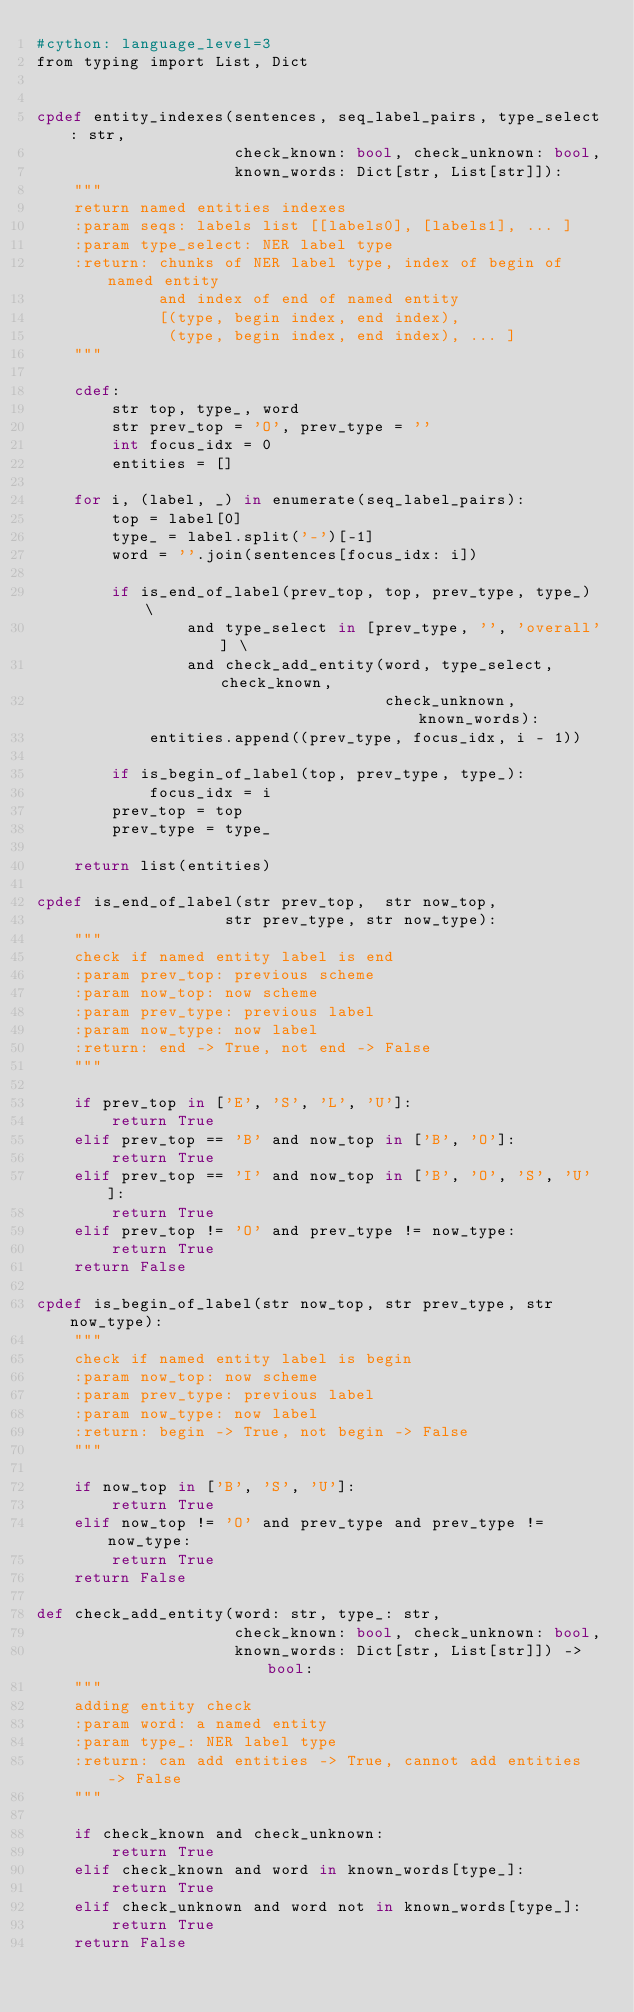Convert code to text. <code><loc_0><loc_0><loc_500><loc_500><_Cython_>#cython: language_level=3
from typing import List, Dict


cpdef entity_indexes(sentences, seq_label_pairs, type_select: str,
                     check_known: bool, check_unknown: bool,
                     known_words: Dict[str, List[str]]):
    """
    return named entities indexes
    :param seqs: labels list [[labels0], [labels1], ... ]
    :param type_select: NER label type
    :return: chunks of NER label type, index of begin of named entity
             and index of end of named entity
             [(type, begin index, end index),
              (type, begin index, end index), ... ]
    """

    cdef:
        str top, type_, word
        str prev_top = 'O', prev_type = ''
        int focus_idx = 0
        entities = []

    for i, (label, _) in enumerate(seq_label_pairs):
        top = label[0]
        type_ = label.split('-')[-1]
        word = ''.join(sentences[focus_idx: i])

        if is_end_of_label(prev_top, top, prev_type, type_) \
                and type_select in [prev_type, '', 'overall'] \
                and check_add_entity(word, type_select, check_known,
                                     check_unknown, known_words):
            entities.append((prev_type, focus_idx, i - 1))

        if is_begin_of_label(top, prev_type, type_):
            focus_idx = i
        prev_top = top
        prev_type = type_

    return list(entities)

cpdef is_end_of_label(str prev_top,  str now_top,
                    str prev_type, str now_type):
    """
    check if named entity label is end
    :param prev_top: previous scheme
    :param now_top: now scheme
    :param prev_type: previous label
    :param now_type: now label
    :return: end -> True, not end -> False
    """

    if prev_top in ['E', 'S', 'L', 'U']:
        return True
    elif prev_top == 'B' and now_top in ['B', 'O']:
        return True
    elif prev_top == 'I' and now_top in ['B', 'O', 'S', 'U']:
        return True
    elif prev_top != 'O' and prev_type != now_type:
        return True
    return False

cpdef is_begin_of_label(str now_top, str prev_type, str now_type):
    """
    check if named entity label is begin
    :param now_top: now scheme
    :param prev_type: previous label
    :param now_type: now label
    :return: begin -> True, not begin -> False
    """

    if now_top in ['B', 'S', 'U']:
        return True
    elif now_top != 'O' and prev_type and prev_type != now_type:
        return True
    return False

def check_add_entity(word: str, type_: str,
                     check_known: bool, check_unknown: bool,
                     known_words: Dict[str, List[str]]) -> bool:
    """
    adding entity check
    :param word: a named entity
    :param type_: NER label type
    :return: can add entities -> True, cannot add entities -> False
    """

    if check_known and check_unknown:
        return True
    elif check_known and word in known_words[type_]:
        return True
    elif check_unknown and word not in known_words[type_]:
        return True
    return False
</code> 